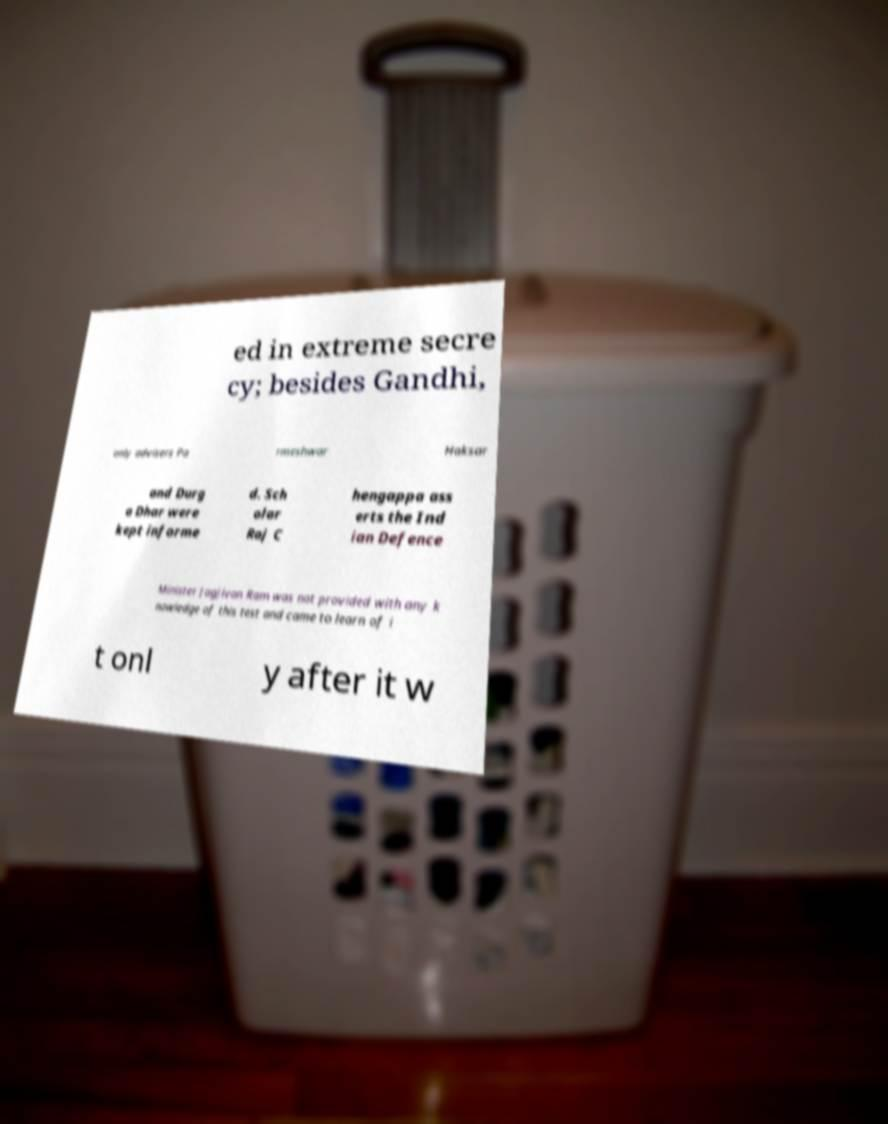There's text embedded in this image that I need extracted. Can you transcribe it verbatim? ed in extreme secre cy; besides Gandhi, only advisers Pa rmeshwar Haksar and Durg a Dhar were kept informe d. Sch olar Raj C hengappa ass erts the Ind ian Defence Minister Jagjivan Ram was not provided with any k nowledge of this test and came to learn of i t onl y after it w 